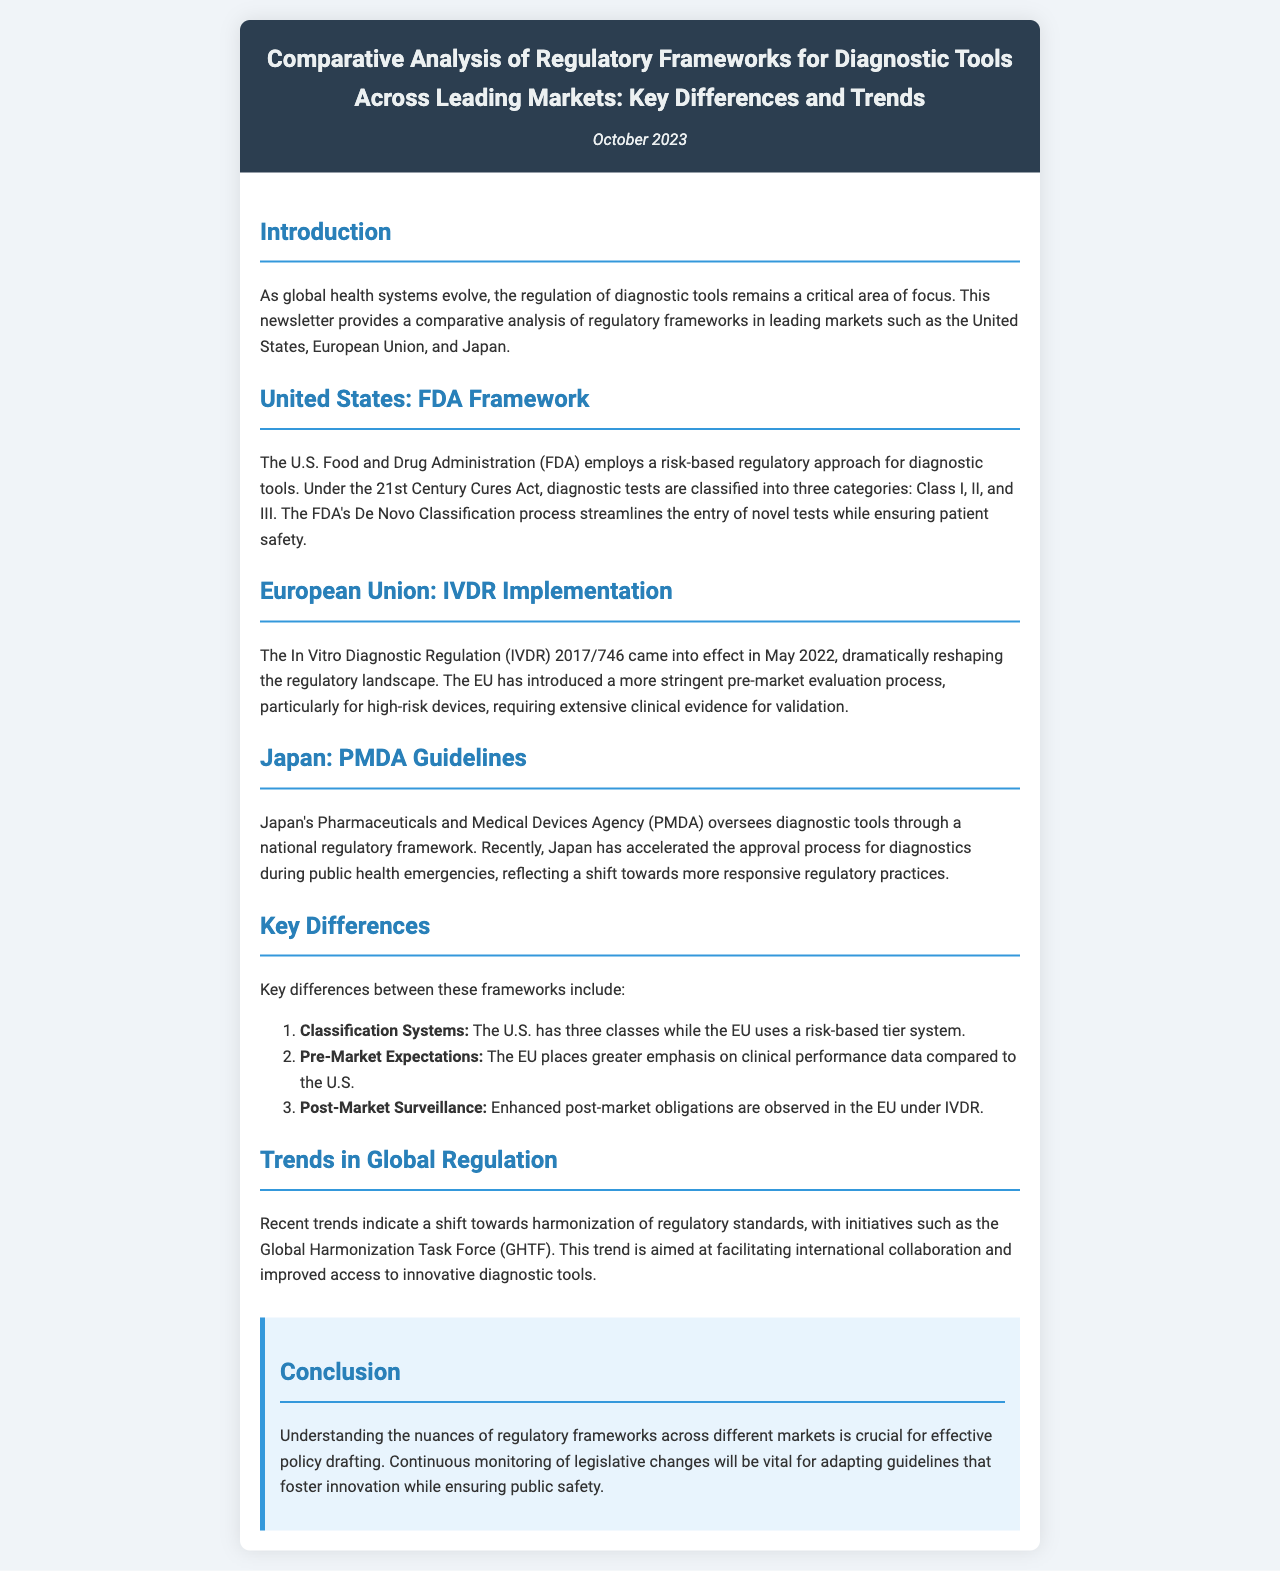what is the title of the newsletter? The title of the newsletter is the heading provided at the top of the document.
Answer: Comparative Analysis of Regulatory Frameworks for Diagnostic Tools Across Leading Markets: Key Differences and Trends when was the newsletter published? The date of publication is mentioned in the document.
Answer: October 2023 which regulatory body oversees diagnostic tools in the United States? The regulatory body responsible for diagnostic tools in the U.S. is stated in the section about the United States.
Answer: FDA what major regulation came into effect in the European Union in May 2022? The specific regulation that significantly changed the regulatory landscape in the EU is mentioned in the relevant section.
Answer: IVDR how many categories does the FDA classify diagnostic tests into? The classification system used by the FDA is discussed, which indicates the number of categories.
Answer: Three what does PMDA stand for in the context of Japan's regulatory framework? The acronym for the agency mentioned in Japan's section is provided.
Answer: Pharmaceuticals and Medical Devices Agency what do recent trends in global regulation indicate? The overall trend discussed in the document is summarized.
Answer: Harmonization of regulatory standards what does the EU require more emphasis on compared to the U.S.? The document contrasts the emphasis placed on certain data in the EU versus the U.S.
Answer: Clinical performance data what is the primary objective of the Global Harmonization Task Force (GHTF)? The document outlines the initiative's goal for improving regulatory conditions.
Answer: Facilitate international collaboration 